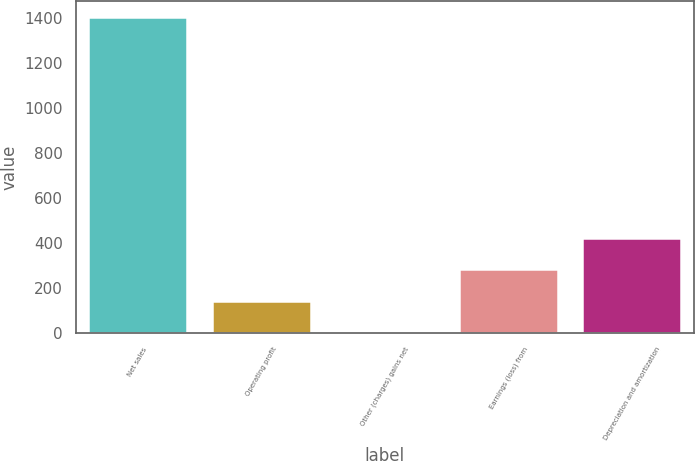Convert chart. <chart><loc_0><loc_0><loc_500><loc_500><bar_chart><fcel>Net sales<fcel>Operating profit<fcel>Other (charges) gains net<fcel>Earnings (loss) from<fcel>Depreciation and amortization<nl><fcel>1406<fcel>143.3<fcel>3<fcel>283.6<fcel>423.9<nl></chart> 